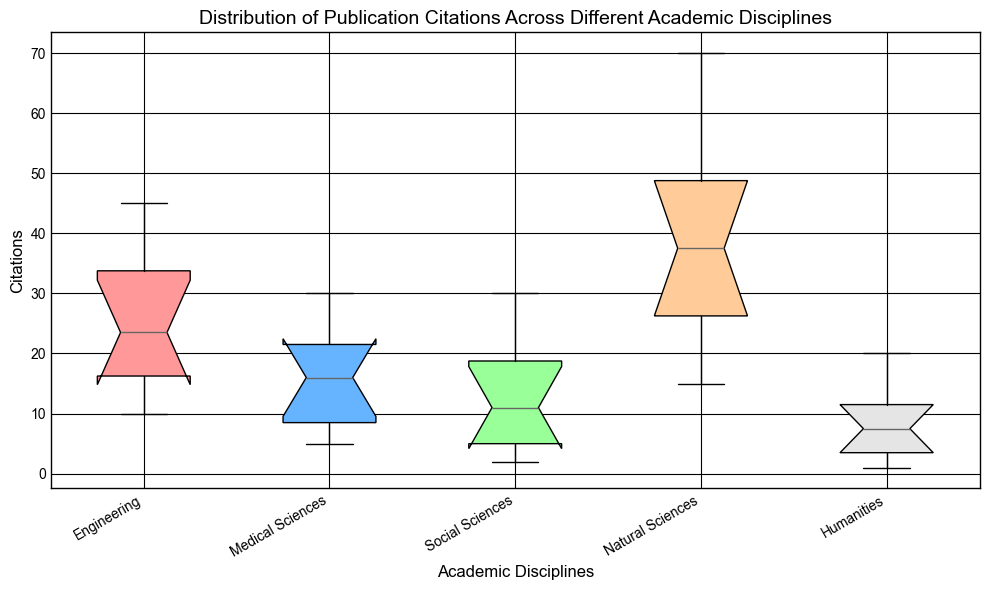What is the median citation count for the Engineering discipline? To determine the median, we observe the box plot for Engineering and look for the middle value. If necessary, we count the number of data points to find the middle value.
Answer: 22.5 Which discipline has the widest interquartile range (IQR) in citations? The IQR can be assessed from the difference in height between the top and bottom of the boxes in the plot. The discipline with the largest difference has the widest IQR.
Answer: Natural Sciences Which discipline has the highest maximum citation count? We look at the highest whisker or outlier points in the box plot, which indicate the maximum citation values for each discipline.
Answer: Natural Sciences Compare the median citation counts between Humanities and Medical Sciences. Which is higher? The middle line inside the boxes represents the median. We compare the medians of both disciplines.
Answer: Medical Sciences Which discipline has the lowest minimum citation count? The lowest whisker or minimum dot in each box plot indicates the minimum citation count.
Answer: Humanities What is the median difference in citations between Natural Sciences and Social Sciences? First, identify the medians for both disciplines from their respective box plots. Calculate the difference by subtracting the two medians.
Answer: 20 Identify the discipline with the smallest range of citation counts. The range is identified by observing the distance between the highest and lowest whiskers or outlier points in each box plot. The smallest distance indicates the smallest range.
Answer: Medical Sciences Which discipline's box plot has the most outliers? Outliers are typically marked as individual points beyond the whiskers in a box plot. Count the outliers for each discipline.
Answer: Social Sciences Compare the upper quartiles (75th percentile) for Engineering and Humanities. Which is higher? The upper quartile is represented by the top of the box in each box plot. Compare the upper quartile values for both disciplines.
Answer: Engineering Which discipline's citation distribution is most skewed? Skewness can often be inferred from the asymmetry in the box plot and the relative lengths of the whiskers. The discipline with the most asymmetric box plot and whiskers is most likely the most skewed.
Answer: Social Sciences 